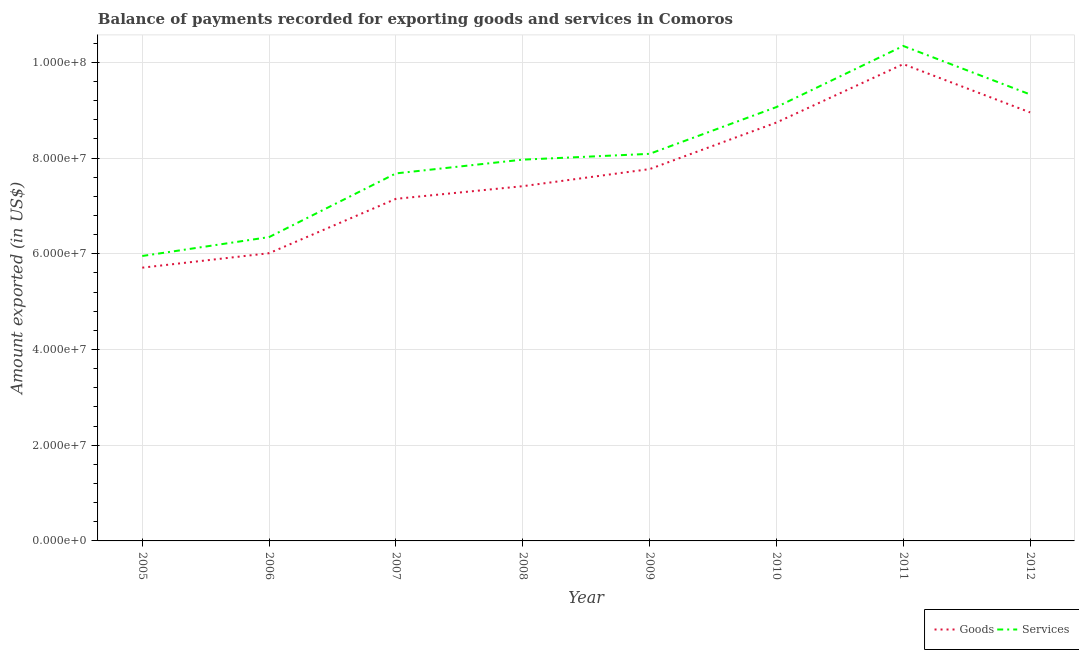Is the number of lines equal to the number of legend labels?
Your answer should be compact. Yes. What is the amount of goods exported in 2006?
Make the answer very short. 6.01e+07. Across all years, what is the maximum amount of services exported?
Your answer should be compact. 1.03e+08. Across all years, what is the minimum amount of goods exported?
Your response must be concise. 5.71e+07. What is the total amount of services exported in the graph?
Your answer should be very brief. 6.48e+08. What is the difference between the amount of services exported in 2010 and that in 2011?
Keep it short and to the point. -1.28e+07. What is the difference between the amount of services exported in 2011 and the amount of goods exported in 2005?
Keep it short and to the point. 4.63e+07. What is the average amount of services exported per year?
Your answer should be compact. 8.10e+07. In the year 2005, what is the difference between the amount of services exported and amount of goods exported?
Offer a very short reply. 2.44e+06. In how many years, is the amount of services exported greater than 68000000 US$?
Make the answer very short. 6. What is the ratio of the amount of goods exported in 2005 to that in 2006?
Your answer should be compact. 0.95. Is the amount of services exported in 2005 less than that in 2008?
Your answer should be compact. Yes. What is the difference between the highest and the second highest amount of services exported?
Your response must be concise. 1.01e+07. What is the difference between the highest and the lowest amount of services exported?
Ensure brevity in your answer.  4.39e+07. In how many years, is the amount of services exported greater than the average amount of services exported taken over all years?
Make the answer very short. 3. What is the difference between two consecutive major ticks on the Y-axis?
Offer a terse response. 2.00e+07. Does the graph contain any zero values?
Your answer should be very brief. No. Does the graph contain grids?
Give a very brief answer. Yes. How are the legend labels stacked?
Provide a short and direct response. Horizontal. What is the title of the graph?
Provide a short and direct response. Balance of payments recorded for exporting goods and services in Comoros. What is the label or title of the X-axis?
Keep it short and to the point. Year. What is the label or title of the Y-axis?
Keep it short and to the point. Amount exported (in US$). What is the Amount exported (in US$) in Goods in 2005?
Make the answer very short. 5.71e+07. What is the Amount exported (in US$) of Services in 2005?
Keep it short and to the point. 5.95e+07. What is the Amount exported (in US$) of Goods in 2006?
Provide a succinct answer. 6.01e+07. What is the Amount exported (in US$) of Services in 2006?
Keep it short and to the point. 6.35e+07. What is the Amount exported (in US$) in Goods in 2007?
Provide a short and direct response. 7.15e+07. What is the Amount exported (in US$) of Services in 2007?
Make the answer very short. 7.68e+07. What is the Amount exported (in US$) in Goods in 2008?
Your answer should be very brief. 7.41e+07. What is the Amount exported (in US$) in Services in 2008?
Keep it short and to the point. 7.97e+07. What is the Amount exported (in US$) in Goods in 2009?
Provide a succinct answer. 7.77e+07. What is the Amount exported (in US$) in Services in 2009?
Ensure brevity in your answer.  8.09e+07. What is the Amount exported (in US$) in Goods in 2010?
Your response must be concise. 8.74e+07. What is the Amount exported (in US$) of Services in 2010?
Provide a succinct answer. 9.07e+07. What is the Amount exported (in US$) of Goods in 2011?
Offer a terse response. 9.96e+07. What is the Amount exported (in US$) in Services in 2011?
Offer a terse response. 1.03e+08. What is the Amount exported (in US$) of Goods in 2012?
Offer a terse response. 8.95e+07. What is the Amount exported (in US$) of Services in 2012?
Provide a short and direct response. 9.33e+07. Across all years, what is the maximum Amount exported (in US$) of Goods?
Offer a very short reply. 9.96e+07. Across all years, what is the maximum Amount exported (in US$) in Services?
Offer a very short reply. 1.03e+08. Across all years, what is the minimum Amount exported (in US$) of Goods?
Keep it short and to the point. 5.71e+07. Across all years, what is the minimum Amount exported (in US$) of Services?
Offer a very short reply. 5.95e+07. What is the total Amount exported (in US$) in Goods in the graph?
Make the answer very short. 6.17e+08. What is the total Amount exported (in US$) of Services in the graph?
Keep it short and to the point. 6.48e+08. What is the difference between the Amount exported (in US$) of Goods in 2005 and that in 2006?
Give a very brief answer. -3.02e+06. What is the difference between the Amount exported (in US$) in Services in 2005 and that in 2006?
Your answer should be compact. -3.95e+06. What is the difference between the Amount exported (in US$) of Goods in 2005 and that in 2007?
Your answer should be very brief. -1.44e+07. What is the difference between the Amount exported (in US$) of Services in 2005 and that in 2007?
Your answer should be very brief. -1.73e+07. What is the difference between the Amount exported (in US$) in Goods in 2005 and that in 2008?
Offer a terse response. -1.70e+07. What is the difference between the Amount exported (in US$) in Services in 2005 and that in 2008?
Keep it short and to the point. -2.01e+07. What is the difference between the Amount exported (in US$) in Goods in 2005 and that in 2009?
Your answer should be compact. -2.06e+07. What is the difference between the Amount exported (in US$) of Services in 2005 and that in 2009?
Ensure brevity in your answer.  -2.13e+07. What is the difference between the Amount exported (in US$) of Goods in 2005 and that in 2010?
Make the answer very short. -3.03e+07. What is the difference between the Amount exported (in US$) in Services in 2005 and that in 2010?
Provide a succinct answer. -3.11e+07. What is the difference between the Amount exported (in US$) in Goods in 2005 and that in 2011?
Keep it short and to the point. -4.25e+07. What is the difference between the Amount exported (in US$) in Services in 2005 and that in 2011?
Ensure brevity in your answer.  -4.39e+07. What is the difference between the Amount exported (in US$) of Goods in 2005 and that in 2012?
Offer a terse response. -3.24e+07. What is the difference between the Amount exported (in US$) of Services in 2005 and that in 2012?
Provide a succinct answer. -3.38e+07. What is the difference between the Amount exported (in US$) of Goods in 2006 and that in 2007?
Keep it short and to the point. -1.14e+07. What is the difference between the Amount exported (in US$) of Services in 2006 and that in 2007?
Offer a terse response. -1.33e+07. What is the difference between the Amount exported (in US$) in Goods in 2006 and that in 2008?
Offer a very short reply. -1.40e+07. What is the difference between the Amount exported (in US$) in Services in 2006 and that in 2008?
Your response must be concise. -1.62e+07. What is the difference between the Amount exported (in US$) of Goods in 2006 and that in 2009?
Keep it short and to the point. -1.76e+07. What is the difference between the Amount exported (in US$) of Services in 2006 and that in 2009?
Give a very brief answer. -1.74e+07. What is the difference between the Amount exported (in US$) of Goods in 2006 and that in 2010?
Your answer should be compact. -2.73e+07. What is the difference between the Amount exported (in US$) in Services in 2006 and that in 2010?
Offer a very short reply. -2.72e+07. What is the difference between the Amount exported (in US$) in Goods in 2006 and that in 2011?
Provide a short and direct response. -3.95e+07. What is the difference between the Amount exported (in US$) in Services in 2006 and that in 2011?
Keep it short and to the point. -3.99e+07. What is the difference between the Amount exported (in US$) in Goods in 2006 and that in 2012?
Provide a short and direct response. -2.94e+07. What is the difference between the Amount exported (in US$) of Services in 2006 and that in 2012?
Provide a short and direct response. -2.98e+07. What is the difference between the Amount exported (in US$) of Goods in 2007 and that in 2008?
Make the answer very short. -2.64e+06. What is the difference between the Amount exported (in US$) of Services in 2007 and that in 2008?
Provide a short and direct response. -2.87e+06. What is the difference between the Amount exported (in US$) in Goods in 2007 and that in 2009?
Provide a succinct answer. -6.22e+06. What is the difference between the Amount exported (in US$) in Services in 2007 and that in 2009?
Provide a short and direct response. -4.09e+06. What is the difference between the Amount exported (in US$) in Goods in 2007 and that in 2010?
Offer a very short reply. -1.59e+07. What is the difference between the Amount exported (in US$) in Services in 2007 and that in 2010?
Offer a very short reply. -1.39e+07. What is the difference between the Amount exported (in US$) of Goods in 2007 and that in 2011?
Your answer should be compact. -2.82e+07. What is the difference between the Amount exported (in US$) in Services in 2007 and that in 2011?
Keep it short and to the point. -2.66e+07. What is the difference between the Amount exported (in US$) in Goods in 2007 and that in 2012?
Provide a succinct answer. -1.81e+07. What is the difference between the Amount exported (in US$) in Services in 2007 and that in 2012?
Keep it short and to the point. -1.65e+07. What is the difference between the Amount exported (in US$) of Goods in 2008 and that in 2009?
Your answer should be very brief. -3.57e+06. What is the difference between the Amount exported (in US$) in Services in 2008 and that in 2009?
Ensure brevity in your answer.  -1.21e+06. What is the difference between the Amount exported (in US$) in Goods in 2008 and that in 2010?
Provide a short and direct response. -1.33e+07. What is the difference between the Amount exported (in US$) of Services in 2008 and that in 2010?
Your response must be concise. -1.10e+07. What is the difference between the Amount exported (in US$) of Goods in 2008 and that in 2011?
Your answer should be very brief. -2.55e+07. What is the difference between the Amount exported (in US$) of Services in 2008 and that in 2011?
Give a very brief answer. -2.38e+07. What is the difference between the Amount exported (in US$) in Goods in 2008 and that in 2012?
Provide a succinct answer. -1.54e+07. What is the difference between the Amount exported (in US$) of Services in 2008 and that in 2012?
Offer a terse response. -1.36e+07. What is the difference between the Amount exported (in US$) in Goods in 2009 and that in 2010?
Make the answer very short. -9.73e+06. What is the difference between the Amount exported (in US$) of Services in 2009 and that in 2010?
Your response must be concise. -9.77e+06. What is the difference between the Amount exported (in US$) in Goods in 2009 and that in 2011?
Ensure brevity in your answer.  -2.19e+07. What is the difference between the Amount exported (in US$) of Services in 2009 and that in 2011?
Keep it short and to the point. -2.25e+07. What is the difference between the Amount exported (in US$) of Goods in 2009 and that in 2012?
Make the answer very short. -1.18e+07. What is the difference between the Amount exported (in US$) of Services in 2009 and that in 2012?
Your response must be concise. -1.24e+07. What is the difference between the Amount exported (in US$) in Goods in 2010 and that in 2011?
Your response must be concise. -1.22e+07. What is the difference between the Amount exported (in US$) of Services in 2010 and that in 2011?
Give a very brief answer. -1.28e+07. What is the difference between the Amount exported (in US$) of Goods in 2010 and that in 2012?
Your response must be concise. -2.11e+06. What is the difference between the Amount exported (in US$) of Services in 2010 and that in 2012?
Your answer should be compact. -2.64e+06. What is the difference between the Amount exported (in US$) in Goods in 2011 and that in 2012?
Ensure brevity in your answer.  1.01e+07. What is the difference between the Amount exported (in US$) of Services in 2011 and that in 2012?
Keep it short and to the point. 1.01e+07. What is the difference between the Amount exported (in US$) in Goods in 2005 and the Amount exported (in US$) in Services in 2006?
Ensure brevity in your answer.  -6.39e+06. What is the difference between the Amount exported (in US$) in Goods in 2005 and the Amount exported (in US$) in Services in 2007?
Your response must be concise. -1.97e+07. What is the difference between the Amount exported (in US$) of Goods in 2005 and the Amount exported (in US$) of Services in 2008?
Make the answer very short. -2.26e+07. What is the difference between the Amount exported (in US$) of Goods in 2005 and the Amount exported (in US$) of Services in 2009?
Your response must be concise. -2.38e+07. What is the difference between the Amount exported (in US$) of Goods in 2005 and the Amount exported (in US$) of Services in 2010?
Your response must be concise. -3.36e+07. What is the difference between the Amount exported (in US$) of Goods in 2005 and the Amount exported (in US$) of Services in 2011?
Offer a terse response. -4.63e+07. What is the difference between the Amount exported (in US$) in Goods in 2005 and the Amount exported (in US$) in Services in 2012?
Keep it short and to the point. -3.62e+07. What is the difference between the Amount exported (in US$) of Goods in 2006 and the Amount exported (in US$) of Services in 2007?
Your answer should be very brief. -1.67e+07. What is the difference between the Amount exported (in US$) in Goods in 2006 and the Amount exported (in US$) in Services in 2008?
Provide a short and direct response. -1.96e+07. What is the difference between the Amount exported (in US$) in Goods in 2006 and the Amount exported (in US$) in Services in 2009?
Make the answer very short. -2.08e+07. What is the difference between the Amount exported (in US$) of Goods in 2006 and the Amount exported (in US$) of Services in 2010?
Provide a short and direct response. -3.05e+07. What is the difference between the Amount exported (in US$) of Goods in 2006 and the Amount exported (in US$) of Services in 2011?
Offer a very short reply. -4.33e+07. What is the difference between the Amount exported (in US$) in Goods in 2006 and the Amount exported (in US$) in Services in 2012?
Ensure brevity in your answer.  -3.32e+07. What is the difference between the Amount exported (in US$) of Goods in 2007 and the Amount exported (in US$) of Services in 2008?
Your answer should be very brief. -8.19e+06. What is the difference between the Amount exported (in US$) in Goods in 2007 and the Amount exported (in US$) in Services in 2009?
Your answer should be very brief. -9.41e+06. What is the difference between the Amount exported (in US$) of Goods in 2007 and the Amount exported (in US$) of Services in 2010?
Keep it short and to the point. -1.92e+07. What is the difference between the Amount exported (in US$) in Goods in 2007 and the Amount exported (in US$) in Services in 2011?
Offer a very short reply. -3.19e+07. What is the difference between the Amount exported (in US$) in Goods in 2007 and the Amount exported (in US$) in Services in 2012?
Provide a short and direct response. -2.18e+07. What is the difference between the Amount exported (in US$) in Goods in 2008 and the Amount exported (in US$) in Services in 2009?
Provide a succinct answer. -6.76e+06. What is the difference between the Amount exported (in US$) of Goods in 2008 and the Amount exported (in US$) of Services in 2010?
Offer a very short reply. -1.65e+07. What is the difference between the Amount exported (in US$) in Goods in 2008 and the Amount exported (in US$) in Services in 2011?
Offer a very short reply. -2.93e+07. What is the difference between the Amount exported (in US$) of Goods in 2008 and the Amount exported (in US$) of Services in 2012?
Keep it short and to the point. -1.92e+07. What is the difference between the Amount exported (in US$) in Goods in 2009 and the Amount exported (in US$) in Services in 2010?
Give a very brief answer. -1.30e+07. What is the difference between the Amount exported (in US$) in Goods in 2009 and the Amount exported (in US$) in Services in 2011?
Give a very brief answer. -2.57e+07. What is the difference between the Amount exported (in US$) in Goods in 2009 and the Amount exported (in US$) in Services in 2012?
Make the answer very short. -1.56e+07. What is the difference between the Amount exported (in US$) of Goods in 2010 and the Amount exported (in US$) of Services in 2011?
Offer a terse response. -1.60e+07. What is the difference between the Amount exported (in US$) of Goods in 2010 and the Amount exported (in US$) of Services in 2012?
Your answer should be compact. -5.87e+06. What is the difference between the Amount exported (in US$) of Goods in 2011 and the Amount exported (in US$) of Services in 2012?
Provide a short and direct response. 6.34e+06. What is the average Amount exported (in US$) of Goods per year?
Ensure brevity in your answer.  7.71e+07. What is the average Amount exported (in US$) in Services per year?
Keep it short and to the point. 8.10e+07. In the year 2005, what is the difference between the Amount exported (in US$) in Goods and Amount exported (in US$) in Services?
Keep it short and to the point. -2.44e+06. In the year 2006, what is the difference between the Amount exported (in US$) of Goods and Amount exported (in US$) of Services?
Offer a very short reply. -3.37e+06. In the year 2007, what is the difference between the Amount exported (in US$) in Goods and Amount exported (in US$) in Services?
Provide a short and direct response. -5.32e+06. In the year 2008, what is the difference between the Amount exported (in US$) of Goods and Amount exported (in US$) of Services?
Your answer should be very brief. -5.55e+06. In the year 2009, what is the difference between the Amount exported (in US$) of Goods and Amount exported (in US$) of Services?
Your answer should be compact. -3.19e+06. In the year 2010, what is the difference between the Amount exported (in US$) of Goods and Amount exported (in US$) of Services?
Offer a terse response. -3.23e+06. In the year 2011, what is the difference between the Amount exported (in US$) of Goods and Amount exported (in US$) of Services?
Your response must be concise. -3.79e+06. In the year 2012, what is the difference between the Amount exported (in US$) of Goods and Amount exported (in US$) of Services?
Your response must be concise. -3.76e+06. What is the ratio of the Amount exported (in US$) in Goods in 2005 to that in 2006?
Offer a terse response. 0.95. What is the ratio of the Amount exported (in US$) of Services in 2005 to that in 2006?
Ensure brevity in your answer.  0.94. What is the ratio of the Amount exported (in US$) in Goods in 2005 to that in 2007?
Keep it short and to the point. 0.8. What is the ratio of the Amount exported (in US$) in Services in 2005 to that in 2007?
Offer a terse response. 0.78. What is the ratio of the Amount exported (in US$) of Goods in 2005 to that in 2008?
Your response must be concise. 0.77. What is the ratio of the Amount exported (in US$) in Services in 2005 to that in 2008?
Ensure brevity in your answer.  0.75. What is the ratio of the Amount exported (in US$) of Goods in 2005 to that in 2009?
Provide a succinct answer. 0.73. What is the ratio of the Amount exported (in US$) in Services in 2005 to that in 2009?
Keep it short and to the point. 0.74. What is the ratio of the Amount exported (in US$) of Goods in 2005 to that in 2010?
Your response must be concise. 0.65. What is the ratio of the Amount exported (in US$) in Services in 2005 to that in 2010?
Keep it short and to the point. 0.66. What is the ratio of the Amount exported (in US$) in Goods in 2005 to that in 2011?
Your response must be concise. 0.57. What is the ratio of the Amount exported (in US$) in Services in 2005 to that in 2011?
Offer a terse response. 0.58. What is the ratio of the Amount exported (in US$) of Goods in 2005 to that in 2012?
Offer a terse response. 0.64. What is the ratio of the Amount exported (in US$) of Services in 2005 to that in 2012?
Provide a succinct answer. 0.64. What is the ratio of the Amount exported (in US$) in Goods in 2006 to that in 2007?
Make the answer very short. 0.84. What is the ratio of the Amount exported (in US$) in Services in 2006 to that in 2007?
Provide a succinct answer. 0.83. What is the ratio of the Amount exported (in US$) in Goods in 2006 to that in 2008?
Give a very brief answer. 0.81. What is the ratio of the Amount exported (in US$) of Services in 2006 to that in 2008?
Ensure brevity in your answer.  0.8. What is the ratio of the Amount exported (in US$) of Goods in 2006 to that in 2009?
Give a very brief answer. 0.77. What is the ratio of the Amount exported (in US$) of Services in 2006 to that in 2009?
Offer a terse response. 0.78. What is the ratio of the Amount exported (in US$) of Goods in 2006 to that in 2010?
Your answer should be compact. 0.69. What is the ratio of the Amount exported (in US$) in Services in 2006 to that in 2010?
Offer a terse response. 0.7. What is the ratio of the Amount exported (in US$) in Goods in 2006 to that in 2011?
Your response must be concise. 0.6. What is the ratio of the Amount exported (in US$) in Services in 2006 to that in 2011?
Your answer should be compact. 0.61. What is the ratio of the Amount exported (in US$) in Goods in 2006 to that in 2012?
Provide a short and direct response. 0.67. What is the ratio of the Amount exported (in US$) of Services in 2006 to that in 2012?
Give a very brief answer. 0.68. What is the ratio of the Amount exported (in US$) of Goods in 2007 to that in 2008?
Provide a short and direct response. 0.96. What is the ratio of the Amount exported (in US$) in Services in 2007 to that in 2008?
Ensure brevity in your answer.  0.96. What is the ratio of the Amount exported (in US$) in Goods in 2007 to that in 2009?
Ensure brevity in your answer.  0.92. What is the ratio of the Amount exported (in US$) of Services in 2007 to that in 2009?
Make the answer very short. 0.95. What is the ratio of the Amount exported (in US$) of Goods in 2007 to that in 2010?
Your answer should be compact. 0.82. What is the ratio of the Amount exported (in US$) of Services in 2007 to that in 2010?
Provide a succinct answer. 0.85. What is the ratio of the Amount exported (in US$) in Goods in 2007 to that in 2011?
Provide a short and direct response. 0.72. What is the ratio of the Amount exported (in US$) in Services in 2007 to that in 2011?
Keep it short and to the point. 0.74. What is the ratio of the Amount exported (in US$) of Goods in 2007 to that in 2012?
Your answer should be compact. 0.8. What is the ratio of the Amount exported (in US$) of Services in 2007 to that in 2012?
Provide a succinct answer. 0.82. What is the ratio of the Amount exported (in US$) in Goods in 2008 to that in 2009?
Your answer should be very brief. 0.95. What is the ratio of the Amount exported (in US$) of Goods in 2008 to that in 2010?
Your answer should be compact. 0.85. What is the ratio of the Amount exported (in US$) in Services in 2008 to that in 2010?
Make the answer very short. 0.88. What is the ratio of the Amount exported (in US$) in Goods in 2008 to that in 2011?
Keep it short and to the point. 0.74. What is the ratio of the Amount exported (in US$) of Services in 2008 to that in 2011?
Your answer should be very brief. 0.77. What is the ratio of the Amount exported (in US$) in Goods in 2008 to that in 2012?
Offer a terse response. 0.83. What is the ratio of the Amount exported (in US$) of Services in 2008 to that in 2012?
Make the answer very short. 0.85. What is the ratio of the Amount exported (in US$) of Goods in 2009 to that in 2010?
Give a very brief answer. 0.89. What is the ratio of the Amount exported (in US$) of Services in 2009 to that in 2010?
Your response must be concise. 0.89. What is the ratio of the Amount exported (in US$) of Goods in 2009 to that in 2011?
Offer a terse response. 0.78. What is the ratio of the Amount exported (in US$) in Services in 2009 to that in 2011?
Offer a very short reply. 0.78. What is the ratio of the Amount exported (in US$) in Goods in 2009 to that in 2012?
Make the answer very short. 0.87. What is the ratio of the Amount exported (in US$) in Services in 2009 to that in 2012?
Keep it short and to the point. 0.87. What is the ratio of the Amount exported (in US$) in Goods in 2010 to that in 2011?
Make the answer very short. 0.88. What is the ratio of the Amount exported (in US$) of Services in 2010 to that in 2011?
Offer a very short reply. 0.88. What is the ratio of the Amount exported (in US$) in Goods in 2010 to that in 2012?
Offer a terse response. 0.98. What is the ratio of the Amount exported (in US$) of Services in 2010 to that in 2012?
Keep it short and to the point. 0.97. What is the ratio of the Amount exported (in US$) of Goods in 2011 to that in 2012?
Your response must be concise. 1.11. What is the ratio of the Amount exported (in US$) of Services in 2011 to that in 2012?
Ensure brevity in your answer.  1.11. What is the difference between the highest and the second highest Amount exported (in US$) in Goods?
Offer a very short reply. 1.01e+07. What is the difference between the highest and the second highest Amount exported (in US$) of Services?
Offer a terse response. 1.01e+07. What is the difference between the highest and the lowest Amount exported (in US$) of Goods?
Ensure brevity in your answer.  4.25e+07. What is the difference between the highest and the lowest Amount exported (in US$) in Services?
Your answer should be compact. 4.39e+07. 